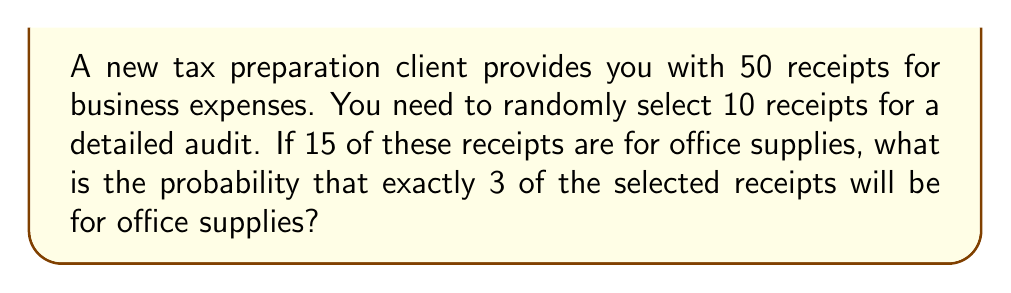Help me with this question. Let's approach this step-by-step using the hypergeometric distribution:

1) We have:
   - Total receipts: $N = 50$
   - Receipts to be selected: $n = 10$
   - Office supply receipts: $K = 15$
   - Office supply receipts we want to select: $k = 3$

2) The probability is given by the hypergeometric distribution formula:

   $$P(X=k) = \frac{\binom{K}{k} \binom{N-K}{n-k}}{\binom{N}{n}}$$

3) Let's calculate each combination:

   $$\binom{15}{3} = \frac{15!}{3!(15-3)!} = 455$$
   
   $$\binom{50-15}{10-3} = \binom{35}{7} = \frac{35!}{7!(35-7)!} = 6,724,520$$
   
   $$\binom{50}{10} = \frac{50!}{10!(50-10)!} = 10,272,278,170$$

4) Now, let's substitute these values into our formula:

   $$P(X=3) = \frac{455 \times 6,724,520}{10,272,278,170}$$

5) Simplifying:

   $$P(X=3) = \frac{3,059,656,600}{10,272,278,170} \approx 0.2978$$

Therefore, the probability of selecting exactly 3 office supply receipts out of 10 randomly selected receipts is approximately 0.2978 or 29.78%.
Answer: $0.2978$ or $29.78\%$ 